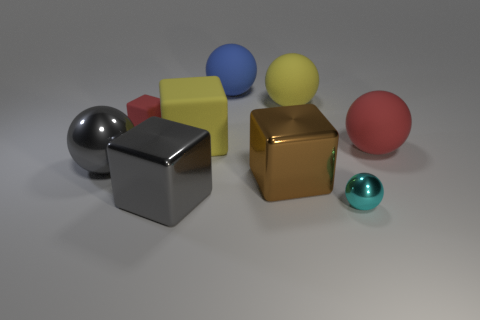There is a brown metal thing that is to the right of the red thing left of the big red ball; how many large gray blocks are to the right of it?
Your answer should be compact. 0. There is a big thing that is both behind the red rubber sphere and right of the brown block; what is its material?
Provide a short and direct response. Rubber. What is the color of the tiny block?
Your response must be concise. Red. Is the number of big red matte balls in front of the large gray shiny ball greater than the number of tiny red rubber objects in front of the big brown metal cube?
Provide a short and direct response. No. There is a small rubber thing that is behind the small cyan ball; what color is it?
Keep it short and to the point. Red. Do the gray thing left of the small red matte thing and the yellow object behind the small cube have the same size?
Offer a very short reply. Yes. How many objects are yellow blocks or yellow rubber balls?
Make the answer very short. 2. What is the gray ball that is in front of the big matte sphere that is to the right of the yellow rubber ball made of?
Keep it short and to the point. Metal. What number of tiny metallic things have the same shape as the big red matte object?
Offer a very short reply. 1. Are there any tiny spheres that have the same color as the big shiny ball?
Keep it short and to the point. No. 